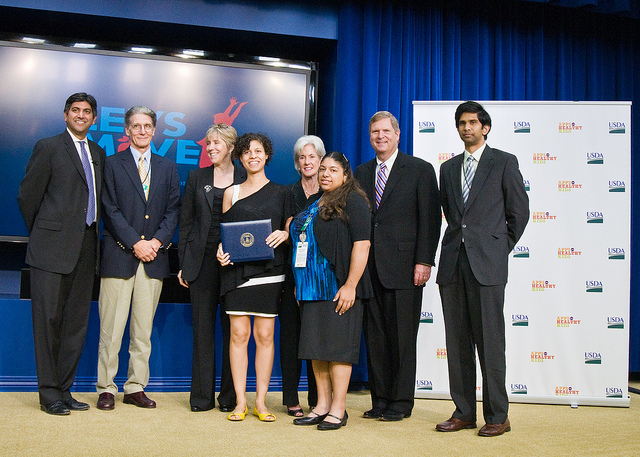Read all the text in this image. VE USDN USDN usda USDN ASDA USDN USDA USDA USDA USDA 